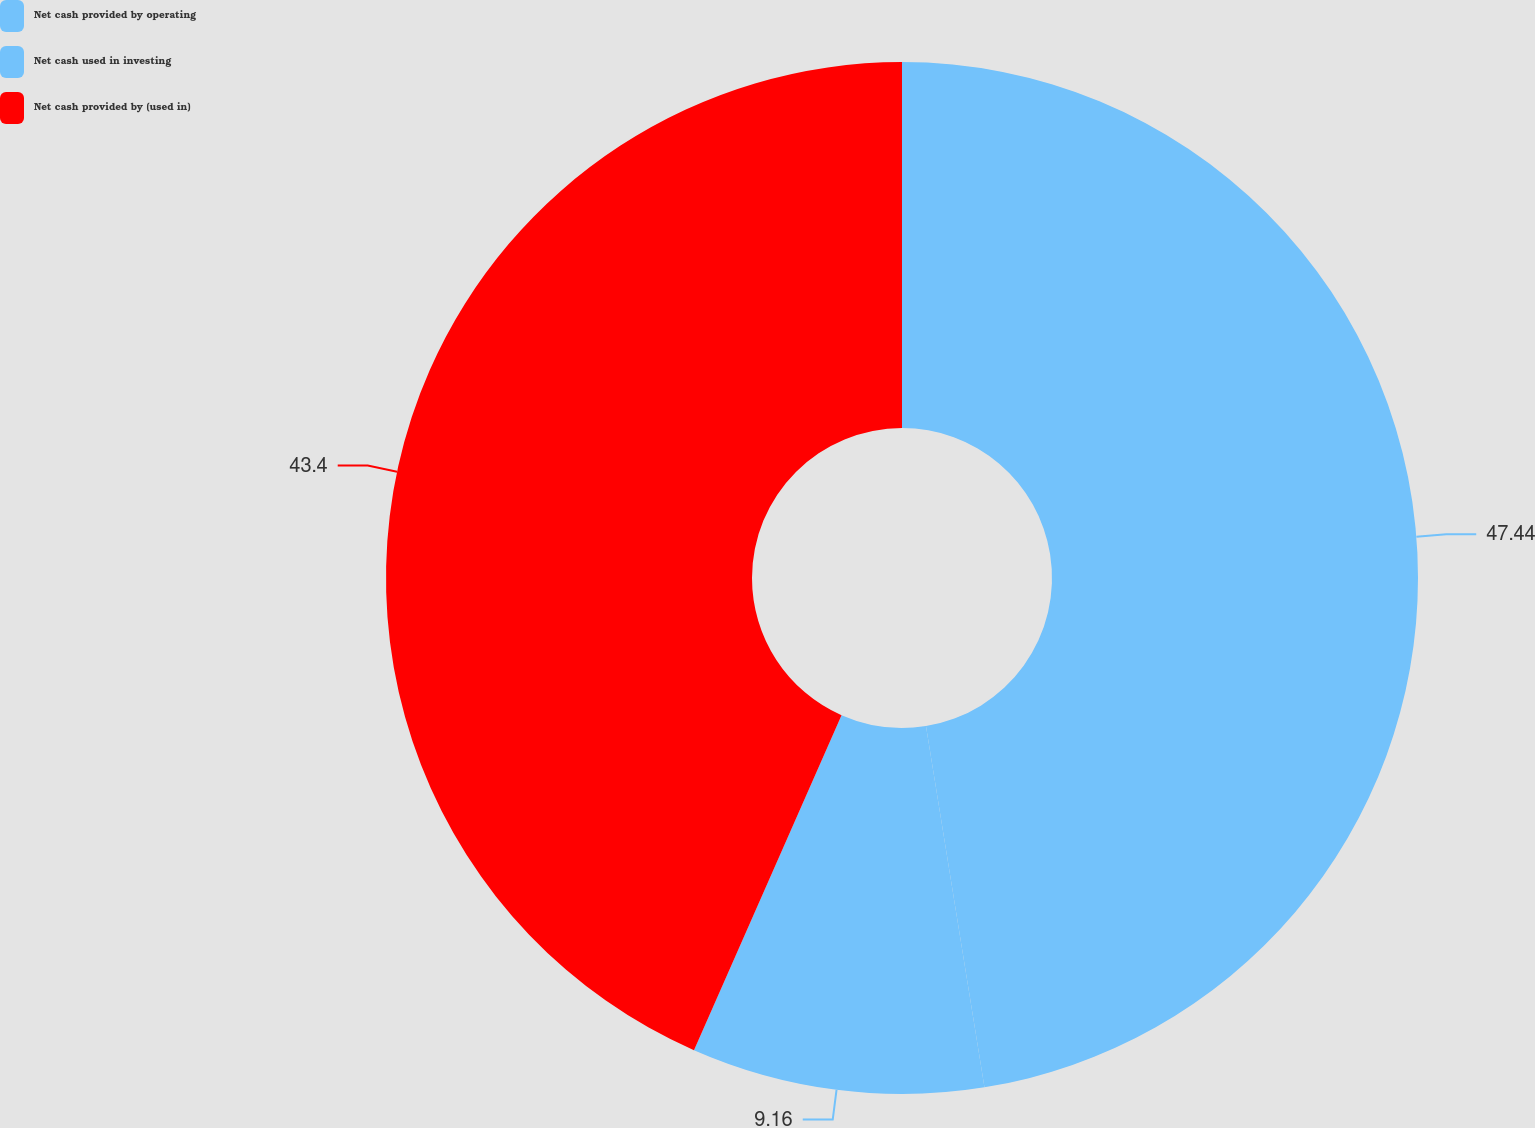<chart> <loc_0><loc_0><loc_500><loc_500><pie_chart><fcel>Net cash provided by operating<fcel>Net cash used in investing<fcel>Net cash provided by (used in)<nl><fcel>47.45%<fcel>9.16%<fcel>43.4%<nl></chart> 